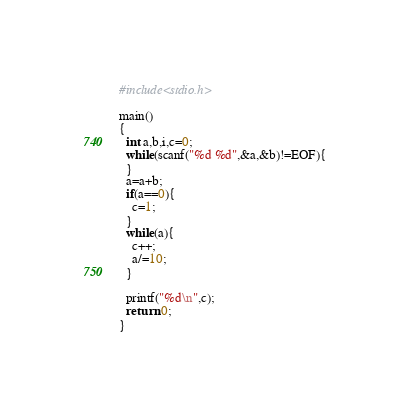<code> <loc_0><loc_0><loc_500><loc_500><_C_>#include<stdio.h>

main()
{
  int a,b,i,c=0;
  while(scanf("%d %d",&a,&b)!=EOF){
  }
  a=a+b;
  if(a==0){
    c=1;
  }
  while(a){
    c++;
    a/=10;
  }
 
  printf("%d\n",c);
  return 0;
}</code> 